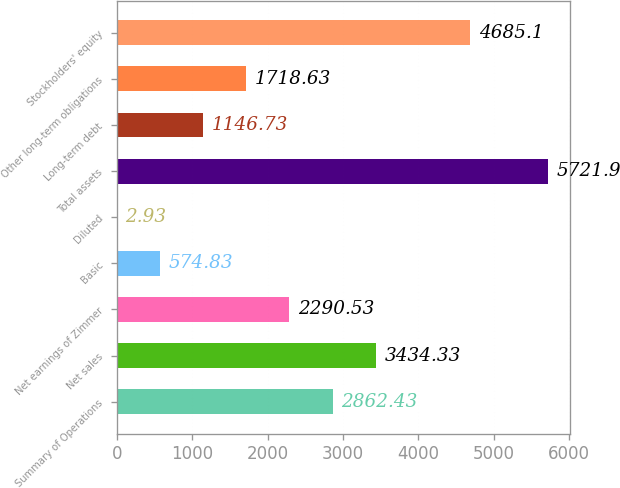Convert chart to OTSL. <chart><loc_0><loc_0><loc_500><loc_500><bar_chart><fcel>Summary of Operations<fcel>Net sales<fcel>Net earnings of Zimmer<fcel>Basic<fcel>Diluted<fcel>Total assets<fcel>Long-term debt<fcel>Other long-term obligations<fcel>Stockholders' equity<nl><fcel>2862.43<fcel>3434.33<fcel>2290.53<fcel>574.83<fcel>2.93<fcel>5721.9<fcel>1146.73<fcel>1718.63<fcel>4685.1<nl></chart> 